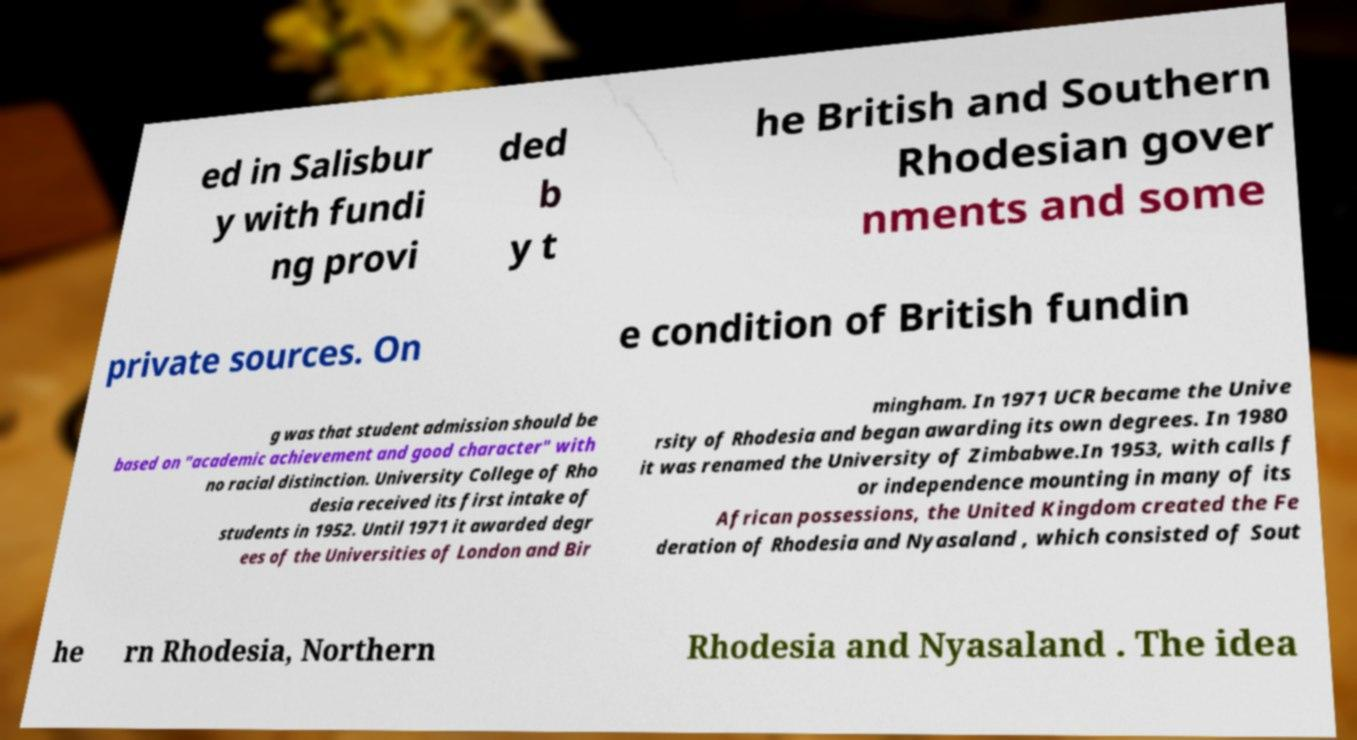Can you accurately transcribe the text from the provided image for me? ed in Salisbur y with fundi ng provi ded b y t he British and Southern Rhodesian gover nments and some private sources. On e condition of British fundin g was that student admission should be based on "academic achievement and good character" with no racial distinction. University College of Rho desia received its first intake of students in 1952. Until 1971 it awarded degr ees of the Universities of London and Bir mingham. In 1971 UCR became the Unive rsity of Rhodesia and began awarding its own degrees. In 1980 it was renamed the University of Zimbabwe.In 1953, with calls f or independence mounting in many of its African possessions, the United Kingdom created the Fe deration of Rhodesia and Nyasaland , which consisted of Sout he rn Rhodesia, Northern Rhodesia and Nyasaland . The idea 